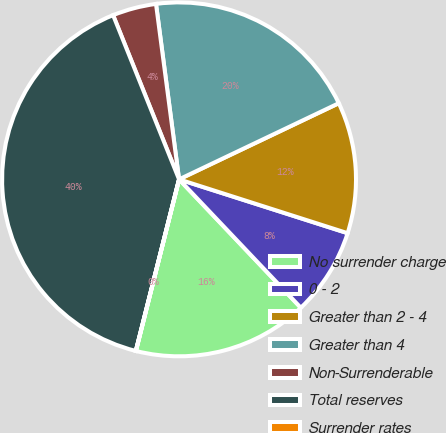Convert chart. <chart><loc_0><loc_0><loc_500><loc_500><pie_chart><fcel>No surrender charge<fcel>0 - 2<fcel>Greater than 2 - 4<fcel>Greater than 4<fcel>Non-Surrenderable<fcel>Total reserves<fcel>Surrender rates<nl><fcel>16.0%<fcel>8.0%<fcel>12.0%<fcel>20.0%<fcel>4.0%<fcel>39.99%<fcel>0.01%<nl></chart> 